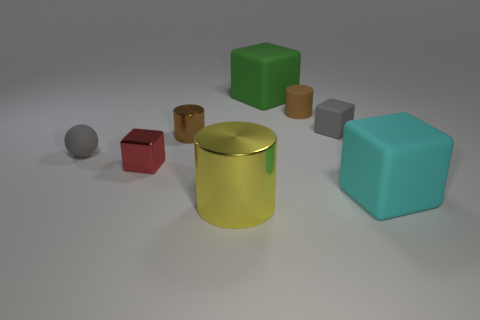Add 1 gray matte spheres. How many objects exist? 9 Subtract all cylinders. How many objects are left? 5 Add 8 large yellow cylinders. How many large yellow cylinders are left? 9 Add 8 large yellow things. How many large yellow things exist? 9 Subtract 1 gray spheres. How many objects are left? 7 Subtract all tiny cylinders. Subtract all brown rubber things. How many objects are left? 5 